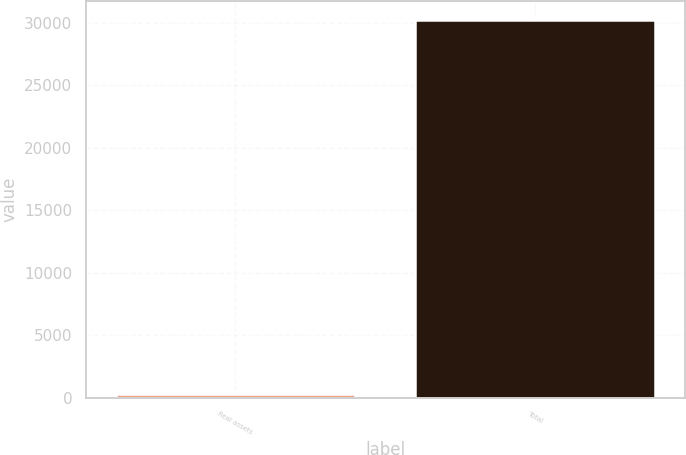Convert chart. <chart><loc_0><loc_0><loc_500><loc_500><bar_chart><fcel>Real assets<fcel>Total<nl><fcel>253<fcel>30200<nl></chart> 